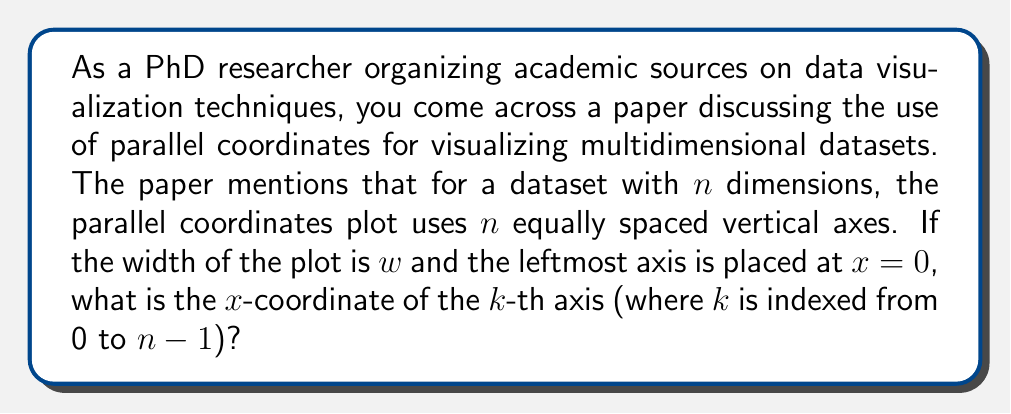Can you answer this question? To solve this problem, we need to understand the geometric principles behind parallel coordinates plots:

1) The plot has a total of $n$ axes for an $n$-dimensional dataset.
2) These axes are equally spaced across the width $w$ of the plot.
3) The leftmost axis (index $k=0$) is at $x=0$.
4) The rightmost axis (index $k=n-1$) is at $x=w$.

To find the $x$-coordinate of the $k$-th axis:

1) Calculate the spacing between axes:
   The total space is $w$, divided into $n-1$ equal intervals.
   Spacing = $\frac{w}{n-1}$

2) The $k$-th axis will be $k$ intervals from the leftmost axis.
   So, its $x$-coordinate will be $k$ times the spacing.

3) Therefore, the $x$-coordinate of the $k$-th axis is:

   $$x_k = k \cdot \frac{w}{n-1}$$

This formula gives us the position of any axis in the parallel coordinates plot, allowing for precise positioning in data visualization implementations.
Answer: The $x$-coordinate of the $k$-th axis in a parallel coordinates plot with $n$ dimensions and width $w$ is:

$$x_k = k \cdot \frac{w}{n-1}$$

where $k$ is indexed from 0 to $n-1$. 